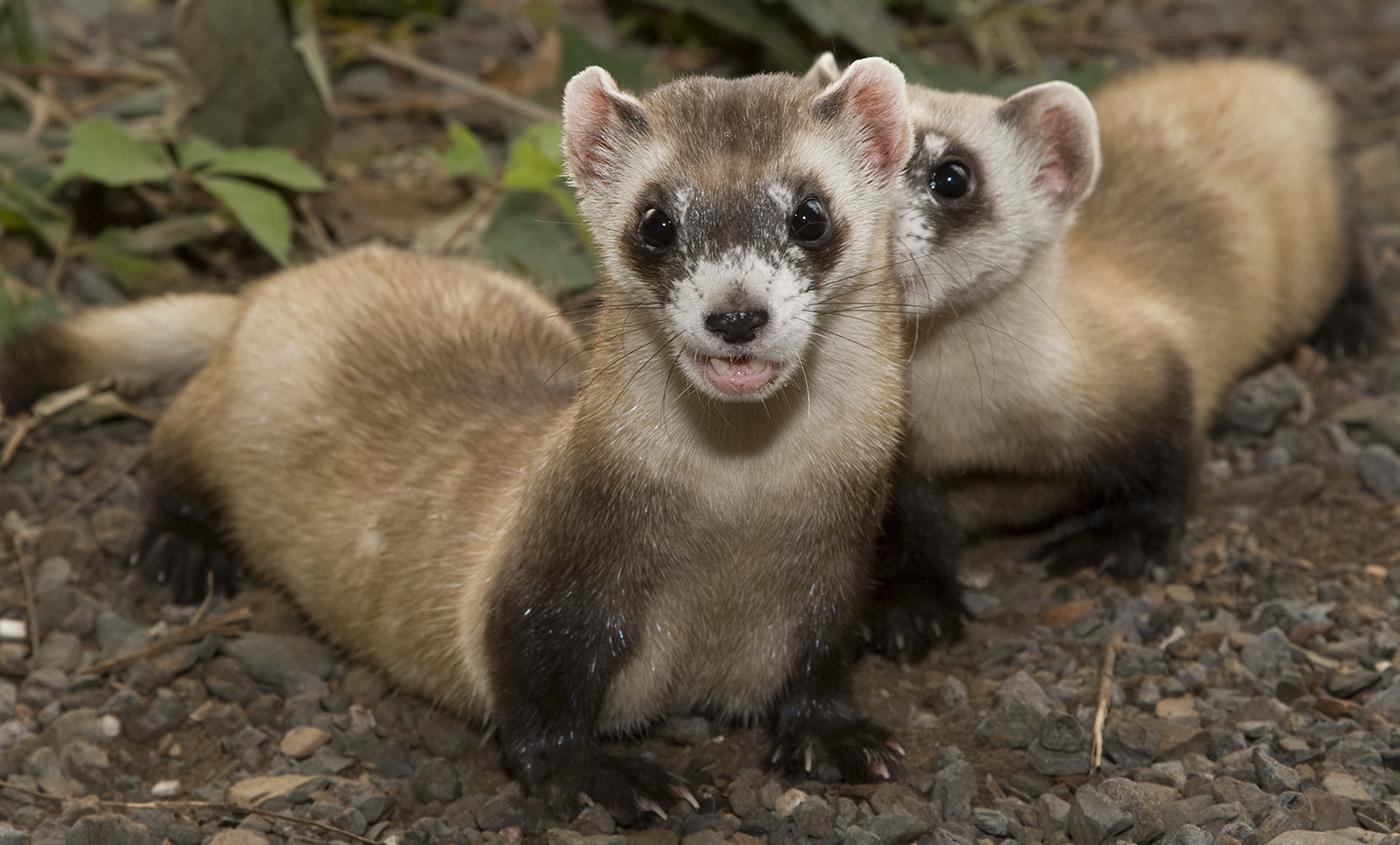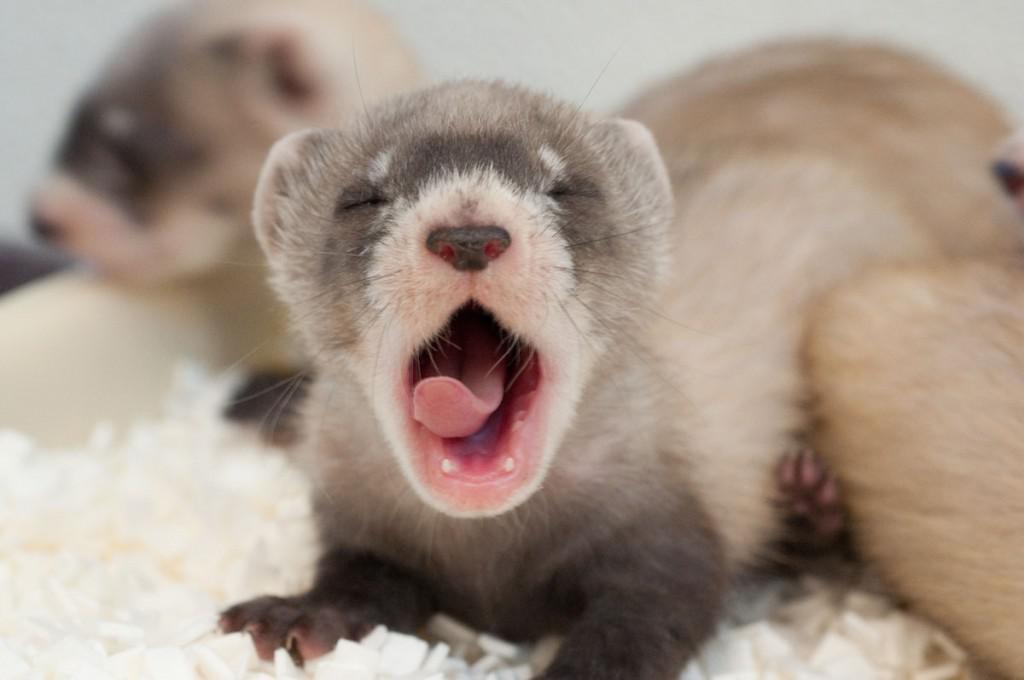The first image is the image on the left, the second image is the image on the right. Considering the images on both sides, is "ferrets mouth is open wide" valid? Answer yes or no. Yes. The first image is the image on the left, the second image is the image on the right. Considering the images on both sides, is "At least one of the images shows a ferret with it's mouth wide open." valid? Answer yes or no. Yes. The first image is the image on the left, the second image is the image on the right. Examine the images to the left and right. Is the description "Two animals are standing on the dirt in one of the images." accurate? Answer yes or no. Yes. The first image is the image on the left, the second image is the image on the right. Considering the images on both sides, is "An image shows a camera-facing ferret emerging from a hole in the ground." valid? Answer yes or no. No. 